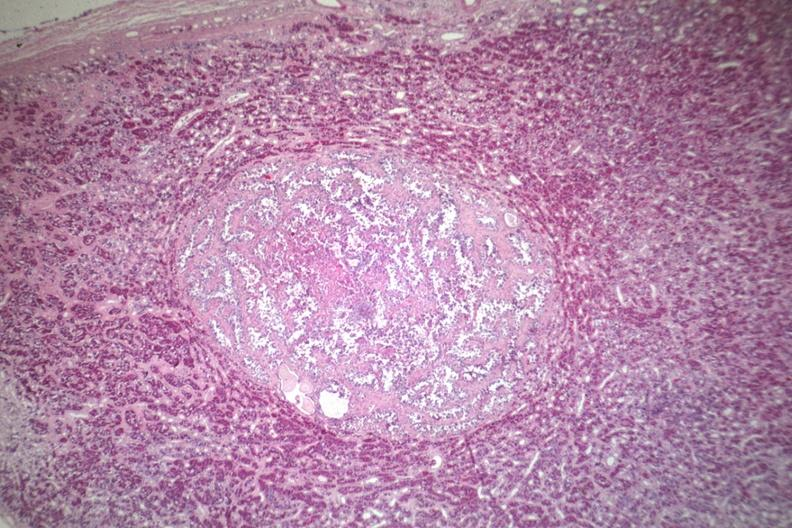what is present?
Answer the question using a single word or phrase. Pituitary 